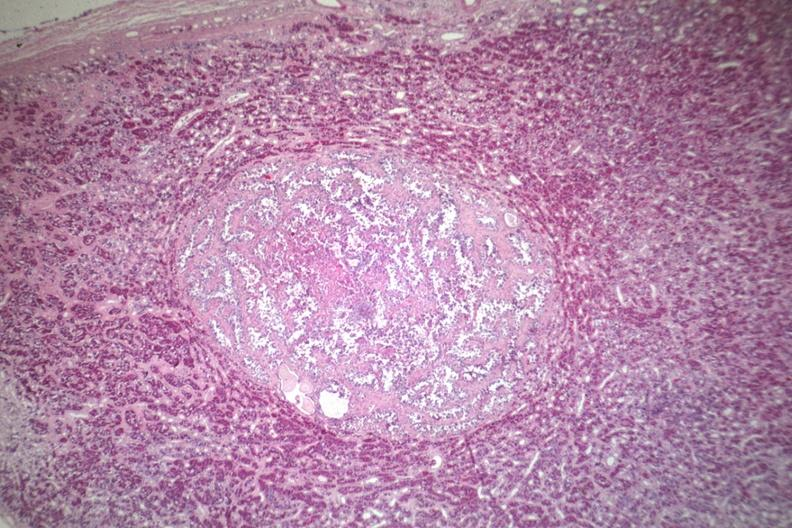what is present?
Answer the question using a single word or phrase. Pituitary 